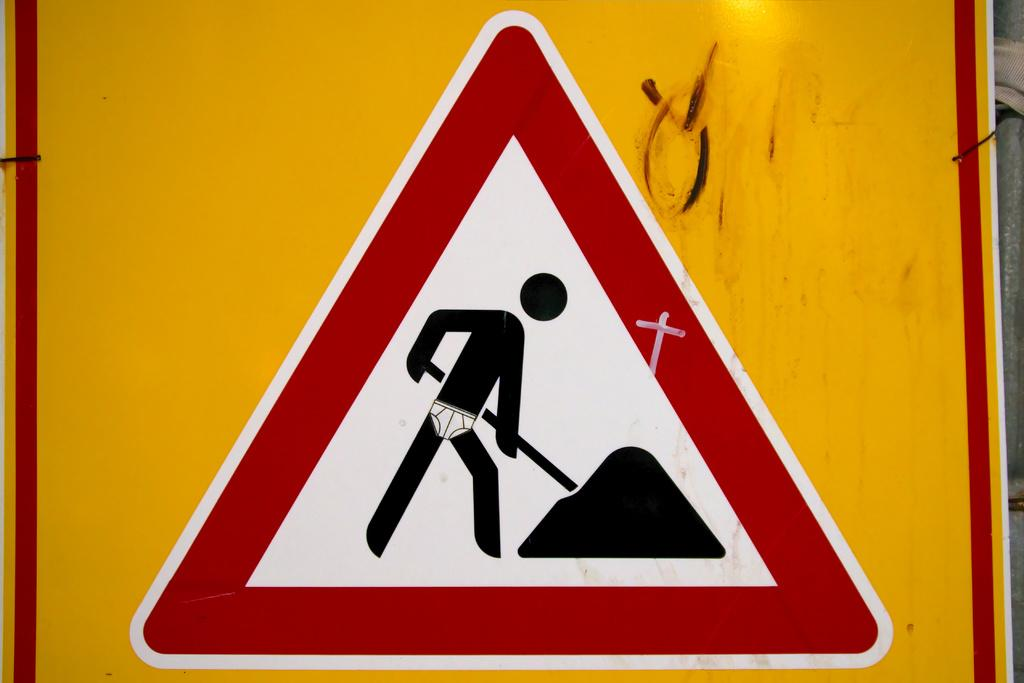Where was the image taken? The image was taken outdoors. What can be seen in the image besides the outdoor setting? There is a sign board in the image. What degree of happiness is displayed on the trees in the image? There are no trees present in the image, and therefore no happiness can be measured on them. 